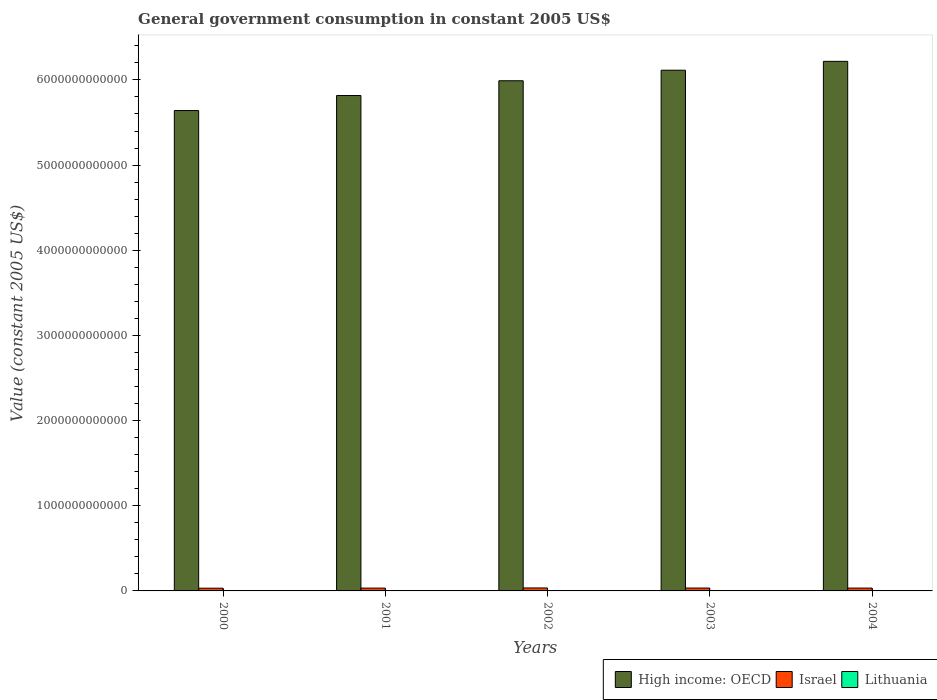How many different coloured bars are there?
Your response must be concise. 3. How many groups of bars are there?
Ensure brevity in your answer.  5. Are the number of bars per tick equal to the number of legend labels?
Your response must be concise. Yes. Are the number of bars on each tick of the X-axis equal?
Offer a terse response. Yes. How many bars are there on the 4th tick from the left?
Your answer should be very brief. 3. How many bars are there on the 2nd tick from the right?
Give a very brief answer. 3. What is the label of the 4th group of bars from the left?
Provide a succinct answer. 2003. What is the government conusmption in Lithuania in 2001?
Your response must be concise. 4.21e+09. Across all years, what is the maximum government conusmption in Lithuania?
Make the answer very short. 4.61e+09. Across all years, what is the minimum government conusmption in Israel?
Make the answer very short. 3.19e+1. In which year was the government conusmption in Israel maximum?
Provide a succinct answer. 2002. What is the total government conusmption in Lithuania in the graph?
Provide a short and direct response. 2.17e+1. What is the difference between the government conusmption in Lithuania in 2003 and that in 2004?
Make the answer very short. -1.83e+08. What is the difference between the government conusmption in High income: OECD in 2003 and the government conusmption in Israel in 2002?
Your response must be concise. 6.08e+12. What is the average government conusmption in Lithuania per year?
Make the answer very short. 4.34e+09. In the year 2001, what is the difference between the government conusmption in Lithuania and government conusmption in Israel?
Provide a short and direct response. -2.89e+1. What is the ratio of the government conusmption in Israel in 2003 to that in 2004?
Your response must be concise. 1.02. Is the government conusmption in High income: OECD in 2001 less than that in 2002?
Offer a terse response. Yes. What is the difference between the highest and the second highest government conusmption in Lithuania?
Provide a succinct answer. 1.83e+08. What is the difference between the highest and the lowest government conusmption in Israel?
Provide a short and direct response. 2.87e+09. In how many years, is the government conusmption in Lithuania greater than the average government conusmption in Lithuania taken over all years?
Your response must be concise. 2. Is the sum of the government conusmption in Lithuania in 2001 and 2004 greater than the maximum government conusmption in High income: OECD across all years?
Provide a succinct answer. No. What does the 3rd bar from the left in 2003 represents?
Give a very brief answer. Lithuania. What does the 3rd bar from the right in 2002 represents?
Your answer should be very brief. High income: OECD. Is it the case that in every year, the sum of the government conusmption in Lithuania and government conusmption in High income: OECD is greater than the government conusmption in Israel?
Your answer should be compact. Yes. How many bars are there?
Provide a succinct answer. 15. Are all the bars in the graph horizontal?
Make the answer very short. No. How many years are there in the graph?
Offer a very short reply. 5. What is the difference between two consecutive major ticks on the Y-axis?
Give a very brief answer. 1.00e+12. Are the values on the major ticks of Y-axis written in scientific E-notation?
Offer a terse response. No. Where does the legend appear in the graph?
Give a very brief answer. Bottom right. How are the legend labels stacked?
Provide a short and direct response. Horizontal. What is the title of the graph?
Offer a terse response. General government consumption in constant 2005 US$. Does "Barbados" appear as one of the legend labels in the graph?
Make the answer very short. No. What is the label or title of the X-axis?
Make the answer very short. Years. What is the label or title of the Y-axis?
Your response must be concise. Value (constant 2005 US$). What is the Value (constant 2005 US$) in High income: OECD in 2000?
Provide a succinct answer. 5.64e+12. What is the Value (constant 2005 US$) of Israel in 2000?
Provide a short and direct response. 3.19e+1. What is the Value (constant 2005 US$) of Lithuania in 2000?
Your response must be concise. 4.14e+09. What is the Value (constant 2005 US$) in High income: OECD in 2001?
Provide a succinct answer. 5.82e+12. What is the Value (constant 2005 US$) of Israel in 2001?
Your answer should be very brief. 3.31e+1. What is the Value (constant 2005 US$) in Lithuania in 2001?
Provide a succinct answer. 4.21e+09. What is the Value (constant 2005 US$) in High income: OECD in 2002?
Offer a terse response. 5.99e+12. What is the Value (constant 2005 US$) in Israel in 2002?
Offer a very short reply. 3.48e+1. What is the Value (constant 2005 US$) in Lithuania in 2002?
Make the answer very short. 4.29e+09. What is the Value (constant 2005 US$) in High income: OECD in 2003?
Give a very brief answer. 6.11e+12. What is the Value (constant 2005 US$) in Israel in 2003?
Your answer should be very brief. 3.38e+1. What is the Value (constant 2005 US$) in Lithuania in 2003?
Your answer should be compact. 4.43e+09. What is the Value (constant 2005 US$) in High income: OECD in 2004?
Provide a succinct answer. 6.22e+12. What is the Value (constant 2005 US$) of Israel in 2004?
Ensure brevity in your answer.  3.33e+1. What is the Value (constant 2005 US$) of Lithuania in 2004?
Your answer should be very brief. 4.61e+09. Across all years, what is the maximum Value (constant 2005 US$) in High income: OECD?
Your answer should be compact. 6.22e+12. Across all years, what is the maximum Value (constant 2005 US$) of Israel?
Offer a terse response. 3.48e+1. Across all years, what is the maximum Value (constant 2005 US$) of Lithuania?
Your response must be concise. 4.61e+09. Across all years, what is the minimum Value (constant 2005 US$) in High income: OECD?
Your response must be concise. 5.64e+12. Across all years, what is the minimum Value (constant 2005 US$) of Israel?
Your answer should be compact. 3.19e+1. Across all years, what is the minimum Value (constant 2005 US$) of Lithuania?
Your response must be concise. 4.14e+09. What is the total Value (constant 2005 US$) in High income: OECD in the graph?
Make the answer very short. 2.98e+13. What is the total Value (constant 2005 US$) of Israel in the graph?
Provide a short and direct response. 1.67e+11. What is the total Value (constant 2005 US$) of Lithuania in the graph?
Your answer should be compact. 2.17e+1. What is the difference between the Value (constant 2005 US$) in High income: OECD in 2000 and that in 2001?
Your answer should be very brief. -1.76e+11. What is the difference between the Value (constant 2005 US$) in Israel in 2000 and that in 2001?
Offer a very short reply. -1.12e+09. What is the difference between the Value (constant 2005 US$) of Lithuania in 2000 and that in 2001?
Offer a terse response. -6.97e+07. What is the difference between the Value (constant 2005 US$) in High income: OECD in 2000 and that in 2002?
Offer a very short reply. -3.50e+11. What is the difference between the Value (constant 2005 US$) in Israel in 2000 and that in 2002?
Your response must be concise. -2.87e+09. What is the difference between the Value (constant 2005 US$) in Lithuania in 2000 and that in 2002?
Provide a succinct answer. -1.55e+08. What is the difference between the Value (constant 2005 US$) in High income: OECD in 2000 and that in 2003?
Give a very brief answer. -4.74e+11. What is the difference between the Value (constant 2005 US$) of Israel in 2000 and that in 2003?
Your response must be concise. -1.87e+09. What is the difference between the Value (constant 2005 US$) of Lithuania in 2000 and that in 2003?
Provide a succinct answer. -2.94e+08. What is the difference between the Value (constant 2005 US$) of High income: OECD in 2000 and that in 2004?
Give a very brief answer. -5.78e+11. What is the difference between the Value (constant 2005 US$) of Israel in 2000 and that in 2004?
Offer a very short reply. -1.35e+09. What is the difference between the Value (constant 2005 US$) in Lithuania in 2000 and that in 2004?
Your answer should be compact. -4.77e+08. What is the difference between the Value (constant 2005 US$) of High income: OECD in 2001 and that in 2002?
Ensure brevity in your answer.  -1.73e+11. What is the difference between the Value (constant 2005 US$) of Israel in 2001 and that in 2002?
Ensure brevity in your answer.  -1.75e+09. What is the difference between the Value (constant 2005 US$) in Lithuania in 2001 and that in 2002?
Your answer should be compact. -8.53e+07. What is the difference between the Value (constant 2005 US$) of High income: OECD in 2001 and that in 2003?
Offer a very short reply. -2.97e+11. What is the difference between the Value (constant 2005 US$) of Israel in 2001 and that in 2003?
Ensure brevity in your answer.  -7.42e+08. What is the difference between the Value (constant 2005 US$) of Lithuania in 2001 and that in 2003?
Your answer should be compact. -2.24e+08. What is the difference between the Value (constant 2005 US$) in High income: OECD in 2001 and that in 2004?
Give a very brief answer. -4.01e+11. What is the difference between the Value (constant 2005 US$) in Israel in 2001 and that in 2004?
Offer a very short reply. -2.25e+08. What is the difference between the Value (constant 2005 US$) of Lithuania in 2001 and that in 2004?
Offer a very short reply. -4.07e+08. What is the difference between the Value (constant 2005 US$) of High income: OECD in 2002 and that in 2003?
Provide a succinct answer. -1.24e+11. What is the difference between the Value (constant 2005 US$) in Israel in 2002 and that in 2003?
Give a very brief answer. 1.01e+09. What is the difference between the Value (constant 2005 US$) of Lithuania in 2002 and that in 2003?
Give a very brief answer. -1.39e+08. What is the difference between the Value (constant 2005 US$) in High income: OECD in 2002 and that in 2004?
Give a very brief answer. -2.28e+11. What is the difference between the Value (constant 2005 US$) in Israel in 2002 and that in 2004?
Provide a succinct answer. 1.52e+09. What is the difference between the Value (constant 2005 US$) in Lithuania in 2002 and that in 2004?
Your answer should be very brief. -3.22e+08. What is the difference between the Value (constant 2005 US$) of High income: OECD in 2003 and that in 2004?
Your response must be concise. -1.04e+11. What is the difference between the Value (constant 2005 US$) of Israel in 2003 and that in 2004?
Keep it short and to the point. 5.17e+08. What is the difference between the Value (constant 2005 US$) of Lithuania in 2003 and that in 2004?
Provide a succinct answer. -1.83e+08. What is the difference between the Value (constant 2005 US$) in High income: OECD in 2000 and the Value (constant 2005 US$) in Israel in 2001?
Provide a succinct answer. 5.61e+12. What is the difference between the Value (constant 2005 US$) in High income: OECD in 2000 and the Value (constant 2005 US$) in Lithuania in 2001?
Make the answer very short. 5.64e+12. What is the difference between the Value (constant 2005 US$) in Israel in 2000 and the Value (constant 2005 US$) in Lithuania in 2001?
Your response must be concise. 2.77e+1. What is the difference between the Value (constant 2005 US$) in High income: OECD in 2000 and the Value (constant 2005 US$) in Israel in 2002?
Provide a short and direct response. 5.61e+12. What is the difference between the Value (constant 2005 US$) in High income: OECD in 2000 and the Value (constant 2005 US$) in Lithuania in 2002?
Your answer should be very brief. 5.64e+12. What is the difference between the Value (constant 2005 US$) in Israel in 2000 and the Value (constant 2005 US$) in Lithuania in 2002?
Provide a succinct answer. 2.77e+1. What is the difference between the Value (constant 2005 US$) in High income: OECD in 2000 and the Value (constant 2005 US$) in Israel in 2003?
Your response must be concise. 5.61e+12. What is the difference between the Value (constant 2005 US$) in High income: OECD in 2000 and the Value (constant 2005 US$) in Lithuania in 2003?
Ensure brevity in your answer.  5.64e+12. What is the difference between the Value (constant 2005 US$) in Israel in 2000 and the Value (constant 2005 US$) in Lithuania in 2003?
Keep it short and to the point. 2.75e+1. What is the difference between the Value (constant 2005 US$) in High income: OECD in 2000 and the Value (constant 2005 US$) in Israel in 2004?
Provide a short and direct response. 5.61e+12. What is the difference between the Value (constant 2005 US$) in High income: OECD in 2000 and the Value (constant 2005 US$) in Lithuania in 2004?
Provide a short and direct response. 5.64e+12. What is the difference between the Value (constant 2005 US$) of Israel in 2000 and the Value (constant 2005 US$) of Lithuania in 2004?
Provide a short and direct response. 2.73e+1. What is the difference between the Value (constant 2005 US$) of High income: OECD in 2001 and the Value (constant 2005 US$) of Israel in 2002?
Give a very brief answer. 5.78e+12. What is the difference between the Value (constant 2005 US$) in High income: OECD in 2001 and the Value (constant 2005 US$) in Lithuania in 2002?
Your answer should be very brief. 5.81e+12. What is the difference between the Value (constant 2005 US$) in Israel in 2001 and the Value (constant 2005 US$) in Lithuania in 2002?
Make the answer very short. 2.88e+1. What is the difference between the Value (constant 2005 US$) of High income: OECD in 2001 and the Value (constant 2005 US$) of Israel in 2003?
Ensure brevity in your answer.  5.78e+12. What is the difference between the Value (constant 2005 US$) in High income: OECD in 2001 and the Value (constant 2005 US$) in Lithuania in 2003?
Your answer should be compact. 5.81e+12. What is the difference between the Value (constant 2005 US$) in Israel in 2001 and the Value (constant 2005 US$) in Lithuania in 2003?
Your answer should be very brief. 2.86e+1. What is the difference between the Value (constant 2005 US$) in High income: OECD in 2001 and the Value (constant 2005 US$) in Israel in 2004?
Ensure brevity in your answer.  5.78e+12. What is the difference between the Value (constant 2005 US$) of High income: OECD in 2001 and the Value (constant 2005 US$) of Lithuania in 2004?
Ensure brevity in your answer.  5.81e+12. What is the difference between the Value (constant 2005 US$) of Israel in 2001 and the Value (constant 2005 US$) of Lithuania in 2004?
Provide a succinct answer. 2.85e+1. What is the difference between the Value (constant 2005 US$) in High income: OECD in 2002 and the Value (constant 2005 US$) in Israel in 2003?
Make the answer very short. 5.96e+12. What is the difference between the Value (constant 2005 US$) in High income: OECD in 2002 and the Value (constant 2005 US$) in Lithuania in 2003?
Your response must be concise. 5.99e+12. What is the difference between the Value (constant 2005 US$) in Israel in 2002 and the Value (constant 2005 US$) in Lithuania in 2003?
Make the answer very short. 3.04e+1. What is the difference between the Value (constant 2005 US$) of High income: OECD in 2002 and the Value (constant 2005 US$) of Israel in 2004?
Keep it short and to the point. 5.96e+12. What is the difference between the Value (constant 2005 US$) in High income: OECD in 2002 and the Value (constant 2005 US$) in Lithuania in 2004?
Your response must be concise. 5.99e+12. What is the difference between the Value (constant 2005 US$) of Israel in 2002 and the Value (constant 2005 US$) of Lithuania in 2004?
Your answer should be compact. 3.02e+1. What is the difference between the Value (constant 2005 US$) in High income: OECD in 2003 and the Value (constant 2005 US$) in Israel in 2004?
Keep it short and to the point. 6.08e+12. What is the difference between the Value (constant 2005 US$) of High income: OECD in 2003 and the Value (constant 2005 US$) of Lithuania in 2004?
Give a very brief answer. 6.11e+12. What is the difference between the Value (constant 2005 US$) in Israel in 2003 and the Value (constant 2005 US$) in Lithuania in 2004?
Your answer should be compact. 2.92e+1. What is the average Value (constant 2005 US$) of High income: OECD per year?
Your answer should be compact. 5.96e+12. What is the average Value (constant 2005 US$) of Israel per year?
Offer a terse response. 3.34e+1. What is the average Value (constant 2005 US$) of Lithuania per year?
Your response must be concise. 4.34e+09. In the year 2000, what is the difference between the Value (constant 2005 US$) of High income: OECD and Value (constant 2005 US$) of Israel?
Make the answer very short. 5.61e+12. In the year 2000, what is the difference between the Value (constant 2005 US$) in High income: OECD and Value (constant 2005 US$) in Lithuania?
Provide a succinct answer. 5.64e+12. In the year 2000, what is the difference between the Value (constant 2005 US$) of Israel and Value (constant 2005 US$) of Lithuania?
Your response must be concise. 2.78e+1. In the year 2001, what is the difference between the Value (constant 2005 US$) of High income: OECD and Value (constant 2005 US$) of Israel?
Your answer should be compact. 5.78e+12. In the year 2001, what is the difference between the Value (constant 2005 US$) of High income: OECD and Value (constant 2005 US$) of Lithuania?
Your answer should be very brief. 5.81e+12. In the year 2001, what is the difference between the Value (constant 2005 US$) in Israel and Value (constant 2005 US$) in Lithuania?
Make the answer very short. 2.89e+1. In the year 2002, what is the difference between the Value (constant 2005 US$) in High income: OECD and Value (constant 2005 US$) in Israel?
Ensure brevity in your answer.  5.96e+12. In the year 2002, what is the difference between the Value (constant 2005 US$) in High income: OECD and Value (constant 2005 US$) in Lithuania?
Your answer should be compact. 5.99e+12. In the year 2002, what is the difference between the Value (constant 2005 US$) in Israel and Value (constant 2005 US$) in Lithuania?
Provide a short and direct response. 3.05e+1. In the year 2003, what is the difference between the Value (constant 2005 US$) of High income: OECD and Value (constant 2005 US$) of Israel?
Keep it short and to the point. 6.08e+12. In the year 2003, what is the difference between the Value (constant 2005 US$) of High income: OECD and Value (constant 2005 US$) of Lithuania?
Your answer should be compact. 6.11e+12. In the year 2003, what is the difference between the Value (constant 2005 US$) in Israel and Value (constant 2005 US$) in Lithuania?
Your answer should be very brief. 2.94e+1. In the year 2004, what is the difference between the Value (constant 2005 US$) of High income: OECD and Value (constant 2005 US$) of Israel?
Ensure brevity in your answer.  6.18e+12. In the year 2004, what is the difference between the Value (constant 2005 US$) of High income: OECD and Value (constant 2005 US$) of Lithuania?
Ensure brevity in your answer.  6.21e+12. In the year 2004, what is the difference between the Value (constant 2005 US$) of Israel and Value (constant 2005 US$) of Lithuania?
Your answer should be very brief. 2.87e+1. What is the ratio of the Value (constant 2005 US$) in High income: OECD in 2000 to that in 2001?
Provide a short and direct response. 0.97. What is the ratio of the Value (constant 2005 US$) in Lithuania in 2000 to that in 2001?
Ensure brevity in your answer.  0.98. What is the ratio of the Value (constant 2005 US$) in High income: OECD in 2000 to that in 2002?
Ensure brevity in your answer.  0.94. What is the ratio of the Value (constant 2005 US$) of Israel in 2000 to that in 2002?
Your answer should be very brief. 0.92. What is the ratio of the Value (constant 2005 US$) of Lithuania in 2000 to that in 2002?
Keep it short and to the point. 0.96. What is the ratio of the Value (constant 2005 US$) of High income: OECD in 2000 to that in 2003?
Ensure brevity in your answer.  0.92. What is the ratio of the Value (constant 2005 US$) of Israel in 2000 to that in 2003?
Keep it short and to the point. 0.94. What is the ratio of the Value (constant 2005 US$) in Lithuania in 2000 to that in 2003?
Your answer should be compact. 0.93. What is the ratio of the Value (constant 2005 US$) of High income: OECD in 2000 to that in 2004?
Provide a short and direct response. 0.91. What is the ratio of the Value (constant 2005 US$) of Israel in 2000 to that in 2004?
Make the answer very short. 0.96. What is the ratio of the Value (constant 2005 US$) of Lithuania in 2000 to that in 2004?
Give a very brief answer. 0.9. What is the ratio of the Value (constant 2005 US$) in High income: OECD in 2001 to that in 2002?
Your answer should be compact. 0.97. What is the ratio of the Value (constant 2005 US$) in Israel in 2001 to that in 2002?
Your response must be concise. 0.95. What is the ratio of the Value (constant 2005 US$) of Lithuania in 2001 to that in 2002?
Your answer should be compact. 0.98. What is the ratio of the Value (constant 2005 US$) of High income: OECD in 2001 to that in 2003?
Provide a succinct answer. 0.95. What is the ratio of the Value (constant 2005 US$) of Israel in 2001 to that in 2003?
Provide a succinct answer. 0.98. What is the ratio of the Value (constant 2005 US$) in Lithuania in 2001 to that in 2003?
Give a very brief answer. 0.95. What is the ratio of the Value (constant 2005 US$) in High income: OECD in 2001 to that in 2004?
Keep it short and to the point. 0.94. What is the ratio of the Value (constant 2005 US$) in Lithuania in 2001 to that in 2004?
Provide a succinct answer. 0.91. What is the ratio of the Value (constant 2005 US$) of High income: OECD in 2002 to that in 2003?
Make the answer very short. 0.98. What is the ratio of the Value (constant 2005 US$) in Israel in 2002 to that in 2003?
Your answer should be compact. 1.03. What is the ratio of the Value (constant 2005 US$) in Lithuania in 2002 to that in 2003?
Your answer should be compact. 0.97. What is the ratio of the Value (constant 2005 US$) of High income: OECD in 2002 to that in 2004?
Your answer should be very brief. 0.96. What is the ratio of the Value (constant 2005 US$) in Israel in 2002 to that in 2004?
Keep it short and to the point. 1.05. What is the ratio of the Value (constant 2005 US$) in Lithuania in 2002 to that in 2004?
Ensure brevity in your answer.  0.93. What is the ratio of the Value (constant 2005 US$) in High income: OECD in 2003 to that in 2004?
Provide a succinct answer. 0.98. What is the ratio of the Value (constant 2005 US$) in Israel in 2003 to that in 2004?
Ensure brevity in your answer.  1.02. What is the ratio of the Value (constant 2005 US$) of Lithuania in 2003 to that in 2004?
Keep it short and to the point. 0.96. What is the difference between the highest and the second highest Value (constant 2005 US$) in High income: OECD?
Make the answer very short. 1.04e+11. What is the difference between the highest and the second highest Value (constant 2005 US$) of Israel?
Ensure brevity in your answer.  1.01e+09. What is the difference between the highest and the second highest Value (constant 2005 US$) in Lithuania?
Make the answer very short. 1.83e+08. What is the difference between the highest and the lowest Value (constant 2005 US$) of High income: OECD?
Provide a short and direct response. 5.78e+11. What is the difference between the highest and the lowest Value (constant 2005 US$) of Israel?
Ensure brevity in your answer.  2.87e+09. What is the difference between the highest and the lowest Value (constant 2005 US$) of Lithuania?
Offer a terse response. 4.77e+08. 